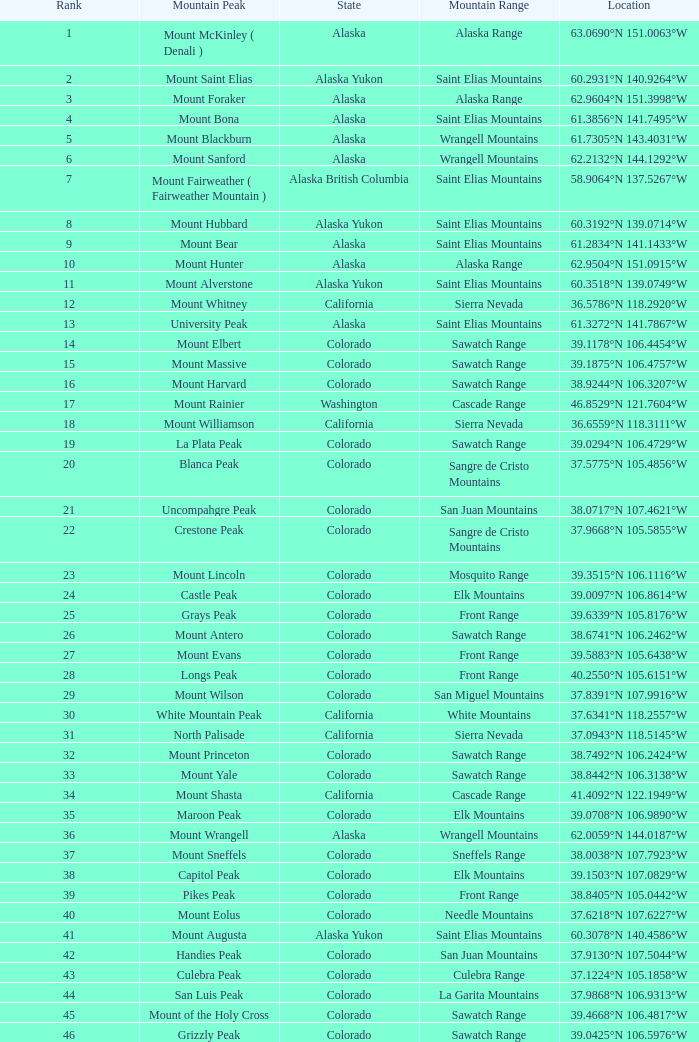What is the mountain peak when the location is 37.5775°n 105.4856°w? Blanca Peak. 